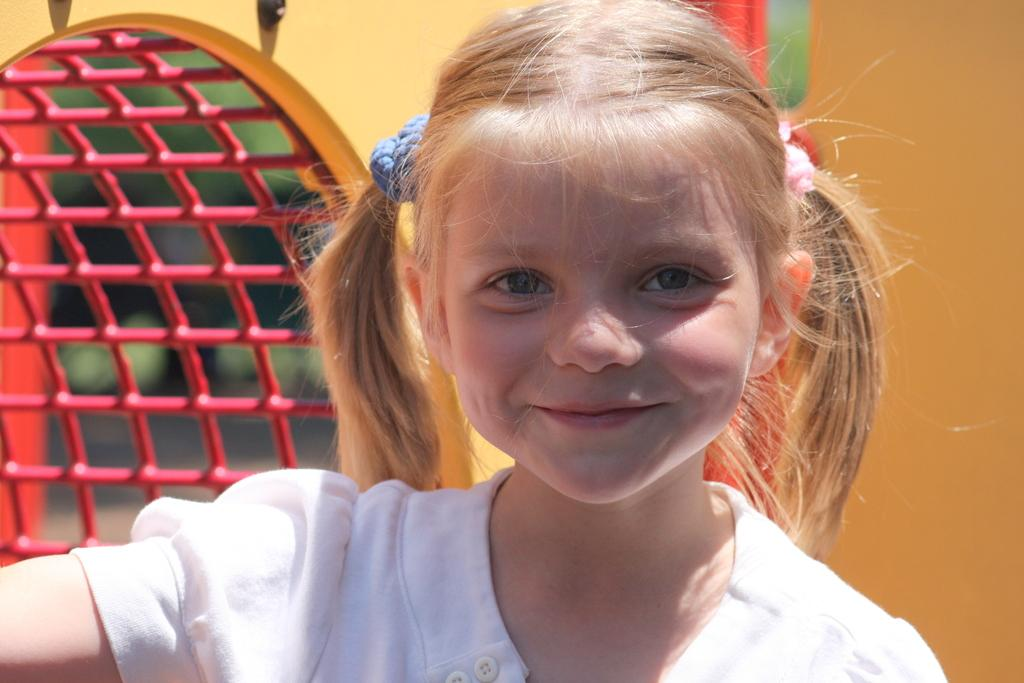Who is the main subject in the image? There is a girl in the center of the image. What is the girl's expression in the image? The girl is smiling in the image. What can be seen in the background of the image? There is a wall and a red color net object in the background of the image. Are there any other objects visible in the background? Yes, there are a few other objects in the background of the image. How many ducks are swimming in the water near the girl in the image? There are no ducks present in the image; it only features a girl, a wall, and a red color net object in the background. 